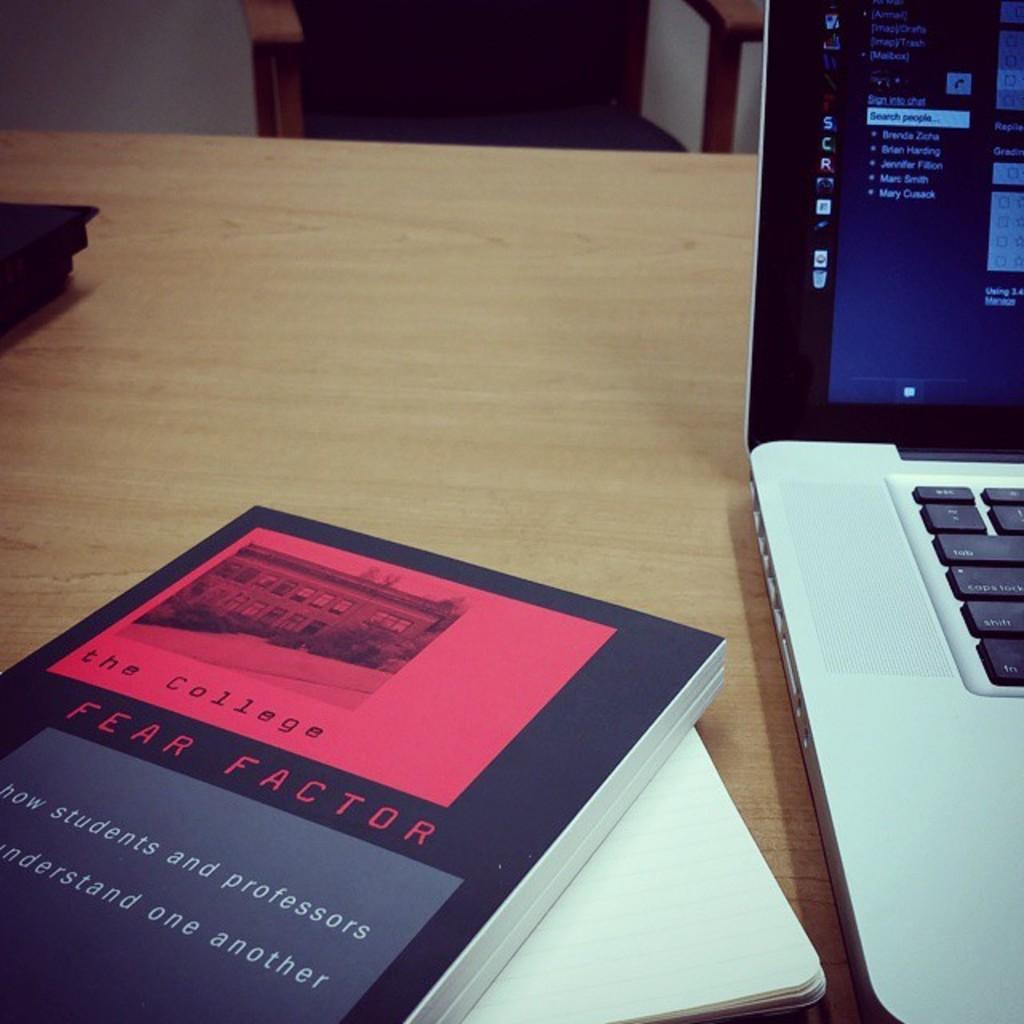<image>
Offer a succinct explanation of the picture presented. The book beside the computer is titled Fear Factor. 